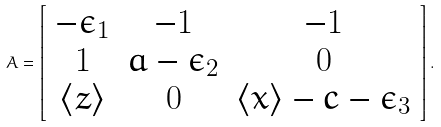Convert formula to latex. <formula><loc_0><loc_0><loc_500><loc_500>\ A = \left [ \begin{array} { c c c } - \epsilon _ { 1 } & - 1 & - 1 \\ 1 & a - \epsilon _ { 2 } & 0 \\ \left \langle z \right \rangle & 0 & \left \langle x \right \rangle - c - \epsilon _ { 3 } \end{array} \right ] .</formula> 